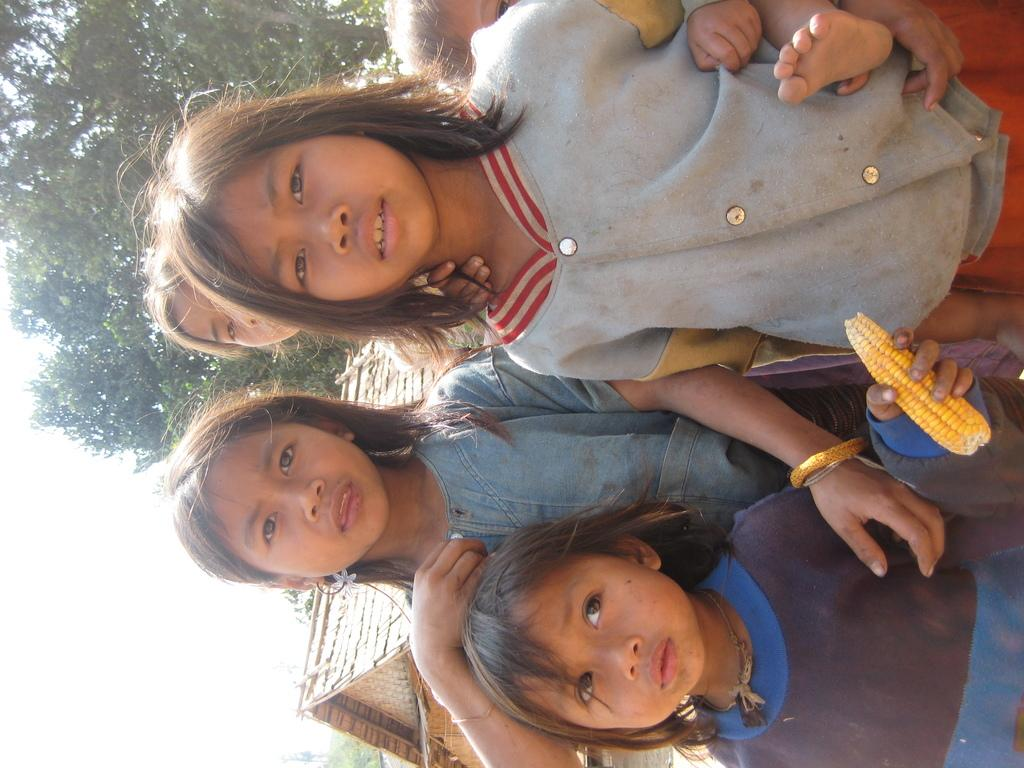What is the main subject of the image? There is a group of people in the image. Can you describe what one of the individuals is holding? A girl is holding corn in the image. What can be seen in the background of the image? There is a hut and trees in the background of the image. What type of dirt is visible on the servant's clothes in the image? There is no servant present in the image, and therefore no dirt on their clothes can be observed. 